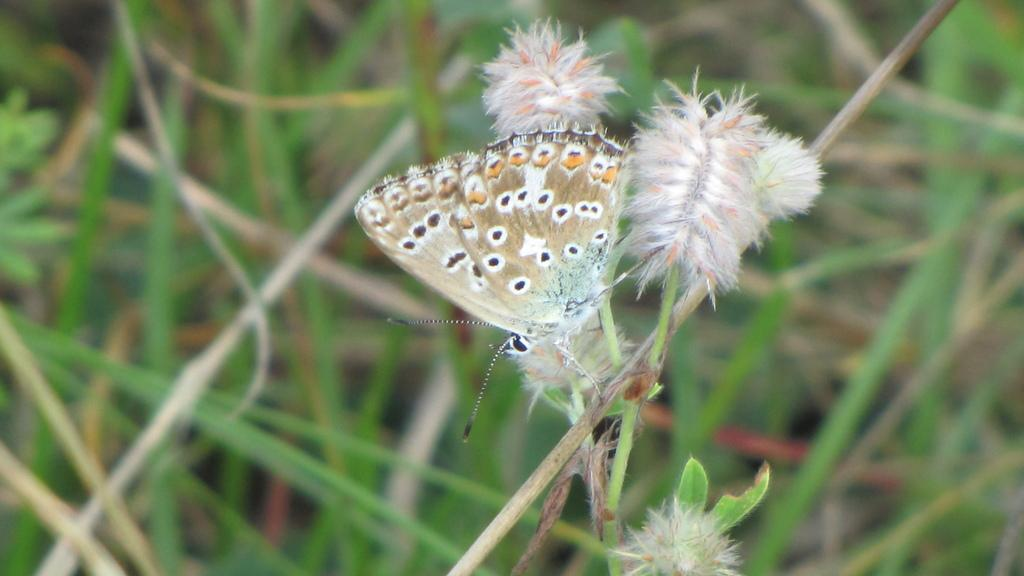What is the main subject of the image? There is a butterfly in the image. Can you describe the background of the image? The background of the image is blurred. What type of form is the butterfly filling out in the image? There is no form present in the image, as it features a butterfly and a blurred background. 